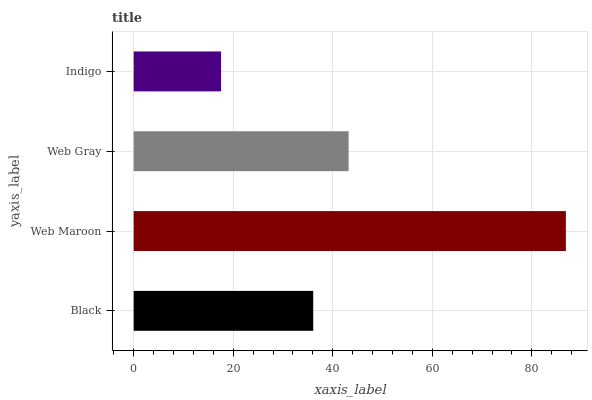Is Indigo the minimum?
Answer yes or no. Yes. Is Web Maroon the maximum?
Answer yes or no. Yes. Is Web Gray the minimum?
Answer yes or no. No. Is Web Gray the maximum?
Answer yes or no. No. Is Web Maroon greater than Web Gray?
Answer yes or no. Yes. Is Web Gray less than Web Maroon?
Answer yes or no. Yes. Is Web Gray greater than Web Maroon?
Answer yes or no. No. Is Web Maroon less than Web Gray?
Answer yes or no. No. Is Web Gray the high median?
Answer yes or no. Yes. Is Black the low median?
Answer yes or no. Yes. Is Web Maroon the high median?
Answer yes or no. No. Is Web Gray the low median?
Answer yes or no. No. 